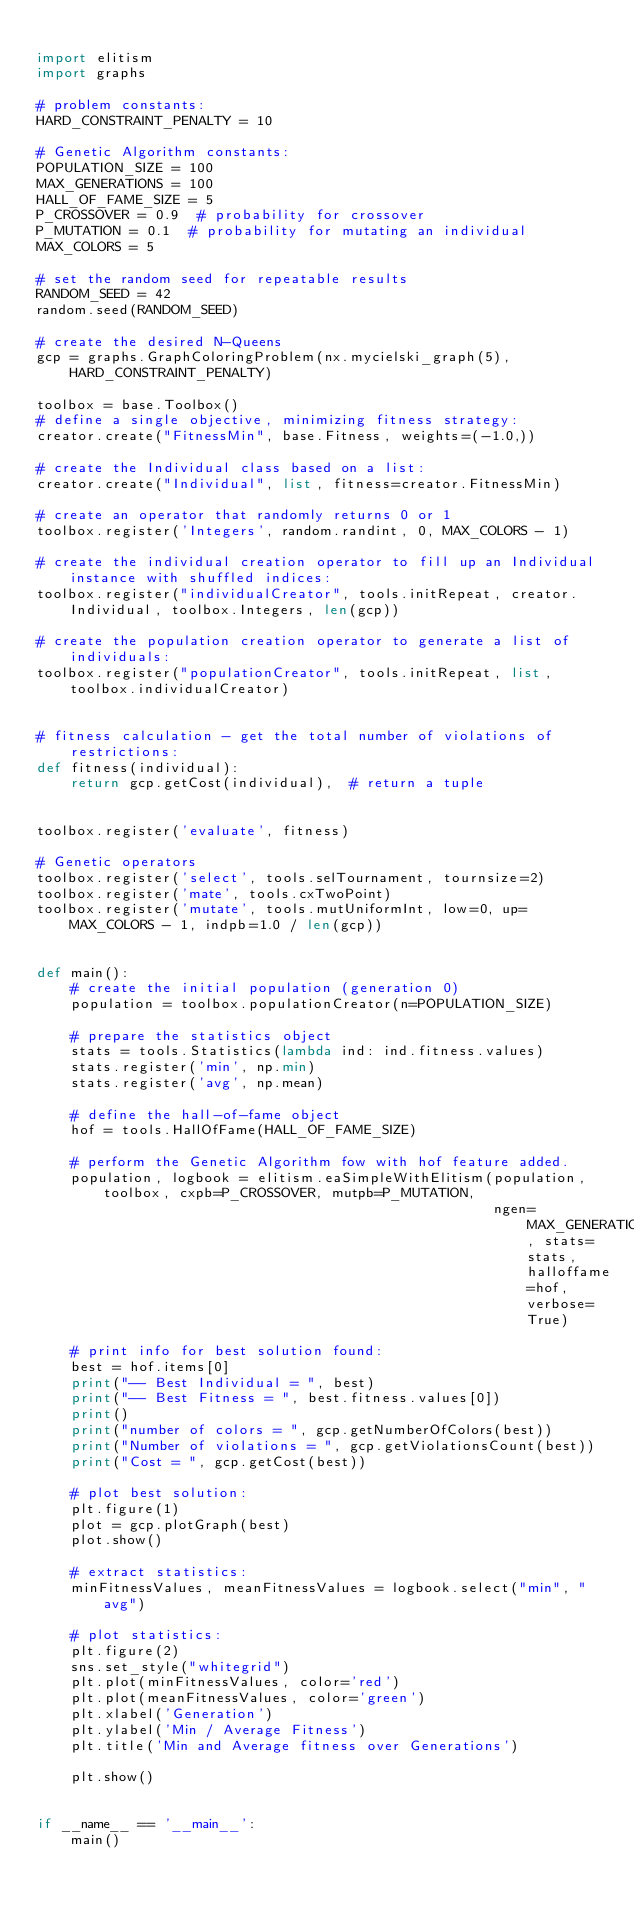Convert code to text. <code><loc_0><loc_0><loc_500><loc_500><_Python_>
import elitism
import graphs

# problem constants:
HARD_CONSTRAINT_PENALTY = 10

# Genetic Algorithm constants:
POPULATION_SIZE = 100
MAX_GENERATIONS = 100
HALL_OF_FAME_SIZE = 5
P_CROSSOVER = 0.9  # probability for crossover
P_MUTATION = 0.1  # probability for mutating an individual
MAX_COLORS = 5

# set the random seed for repeatable results
RANDOM_SEED = 42
random.seed(RANDOM_SEED)

# create the desired N-Queens
gcp = graphs.GraphColoringProblem(nx.mycielski_graph(5), HARD_CONSTRAINT_PENALTY)

toolbox = base.Toolbox()
# define a single objective, minimizing fitness strategy:
creator.create("FitnessMin", base.Fitness, weights=(-1.0,))

# create the Individual class based on a list:
creator.create("Individual", list, fitness=creator.FitnessMin)

# create an operator that randomly returns 0 or 1
toolbox.register('Integers', random.randint, 0, MAX_COLORS - 1)

# create the individual creation operator to fill up an Individual instance with shuffled indices:
toolbox.register("individualCreator", tools.initRepeat, creator.Individual, toolbox.Integers, len(gcp))

# create the population creation operator to generate a list of individuals:
toolbox.register("populationCreator", tools.initRepeat, list, toolbox.individualCreator)


# fitness calculation - get the total number of violations of restrictions:
def fitness(individual):
    return gcp.getCost(individual),  # return a tuple


toolbox.register('evaluate', fitness)

# Genetic operators
toolbox.register('select', tools.selTournament, tournsize=2)
toolbox.register('mate', tools.cxTwoPoint)
toolbox.register('mutate', tools.mutUniformInt, low=0, up=MAX_COLORS - 1, indpb=1.0 / len(gcp))


def main():
    # create the initial population (generation 0)
    population = toolbox.populationCreator(n=POPULATION_SIZE)

    # prepare the statistics object
    stats = tools.Statistics(lambda ind: ind.fitness.values)
    stats.register('min', np.min)
    stats.register('avg', np.mean)

    # define the hall-of-fame object
    hof = tools.HallOfFame(HALL_OF_FAME_SIZE)

    # perform the Genetic Algorithm fow with hof feature added.
    population, logbook = elitism.eaSimpleWithElitism(population, toolbox, cxpb=P_CROSSOVER, mutpb=P_MUTATION,
                                                      ngen=MAX_GENERATIONS, stats=stats, halloffame=hof, verbose=True)

    # print info for best solution found:
    best = hof.items[0]
    print("-- Best Individual = ", best)
    print("-- Best Fitness = ", best.fitness.values[0])
    print()
    print("number of colors = ", gcp.getNumberOfColors(best))
    print("Number of violations = ", gcp.getViolationsCount(best))
    print("Cost = ", gcp.getCost(best))

    # plot best solution:
    plt.figure(1)
    plot = gcp.plotGraph(best)
    plot.show()

    # extract statistics:
    minFitnessValues, meanFitnessValues = logbook.select("min", "avg")

    # plot statistics:
    plt.figure(2)
    sns.set_style("whitegrid")
    plt.plot(minFitnessValues, color='red')
    plt.plot(meanFitnessValues, color='green')
    plt.xlabel('Generation')
    plt.ylabel('Min / Average Fitness')
    plt.title('Min and Average fitness over Generations')

    plt.show()


if __name__ == '__main__':
    main()
</code> 